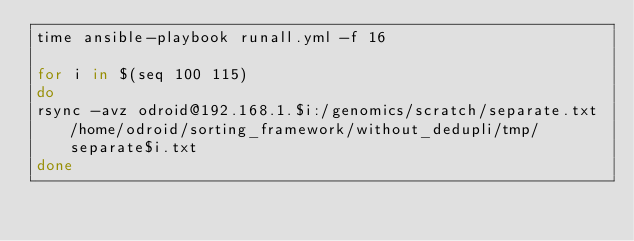Convert code to text. <code><loc_0><loc_0><loc_500><loc_500><_Bash_>time ansible-playbook runall.yml -f 16

for i in $(seq 100 115)
do
rsync -avz odroid@192.168.1.$i:/genomics/scratch/separate.txt /home/odroid/sorting_framework/without_dedupli/tmp/separate$i.txt
done</code> 